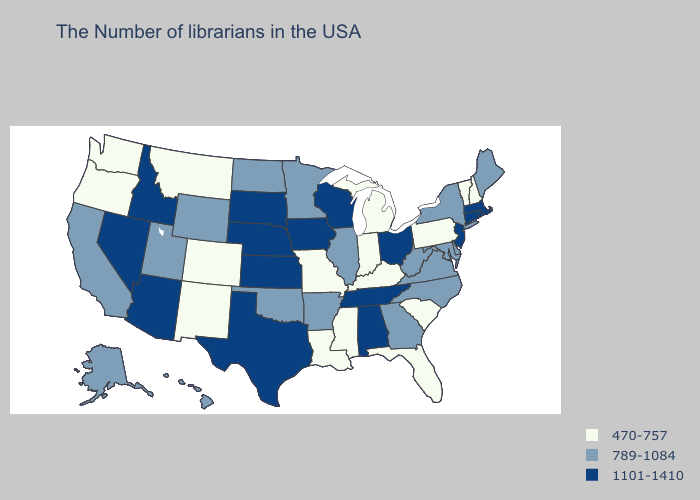What is the lowest value in states that border Arizona?
Give a very brief answer. 470-757. Does Wyoming have the lowest value in the West?
Concise answer only. No. What is the highest value in states that border Georgia?
Give a very brief answer. 1101-1410. Name the states that have a value in the range 1101-1410?
Keep it brief. Massachusetts, Rhode Island, Connecticut, New Jersey, Ohio, Alabama, Tennessee, Wisconsin, Iowa, Kansas, Nebraska, Texas, South Dakota, Arizona, Idaho, Nevada. Among the states that border Utah , which have the lowest value?
Short answer required. Colorado, New Mexico. Among the states that border Georgia , does Florida have the highest value?
Quick response, please. No. What is the lowest value in the West?
Answer briefly. 470-757. Does the first symbol in the legend represent the smallest category?
Short answer required. Yes. Among the states that border Georgia , which have the highest value?
Answer briefly. Alabama, Tennessee. Does the first symbol in the legend represent the smallest category?
Short answer required. Yes. Does the map have missing data?
Answer briefly. No. Which states have the lowest value in the USA?
Short answer required. New Hampshire, Vermont, Pennsylvania, South Carolina, Florida, Michigan, Kentucky, Indiana, Mississippi, Louisiana, Missouri, Colorado, New Mexico, Montana, Washington, Oregon. Name the states that have a value in the range 1101-1410?
Give a very brief answer. Massachusetts, Rhode Island, Connecticut, New Jersey, Ohio, Alabama, Tennessee, Wisconsin, Iowa, Kansas, Nebraska, Texas, South Dakota, Arizona, Idaho, Nevada. 